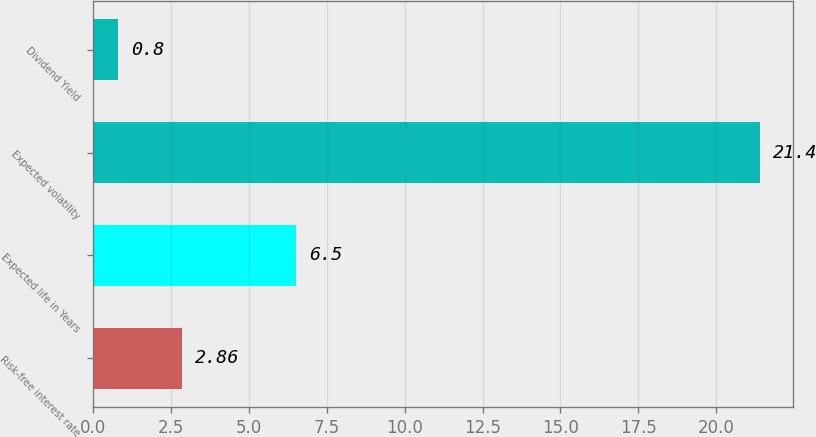<chart> <loc_0><loc_0><loc_500><loc_500><bar_chart><fcel>Risk-free interest rate<fcel>Expected life in Years<fcel>Expected volatility<fcel>Dividend Yield<nl><fcel>2.86<fcel>6.5<fcel>21.4<fcel>0.8<nl></chart> 